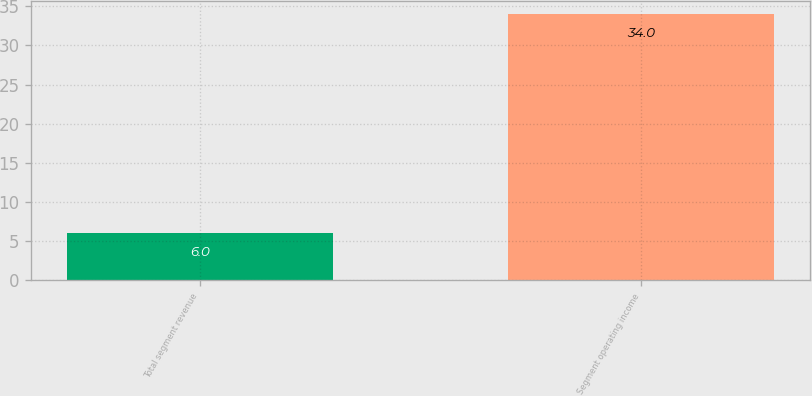Convert chart. <chart><loc_0><loc_0><loc_500><loc_500><bar_chart><fcel>Total segment revenue<fcel>Segment operating income<nl><fcel>6<fcel>34<nl></chart> 